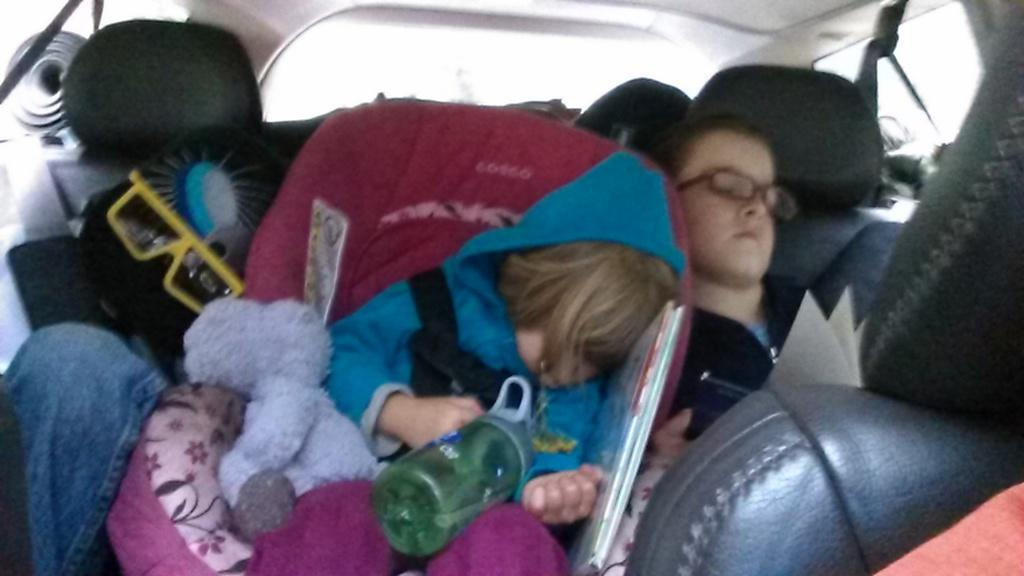Who or what can be seen in the image? There are people in the image. Where are the people located? The people are sitting inside a vehicle. What are the people doing in the image? The people are holding objects in their hands. What type of quiver can be seen on the person's back in the image? There is no quiver present on anyone's back in the image. How many beads are visible on the person's necklace in the image? There is no necklace or beads visible in the image. 